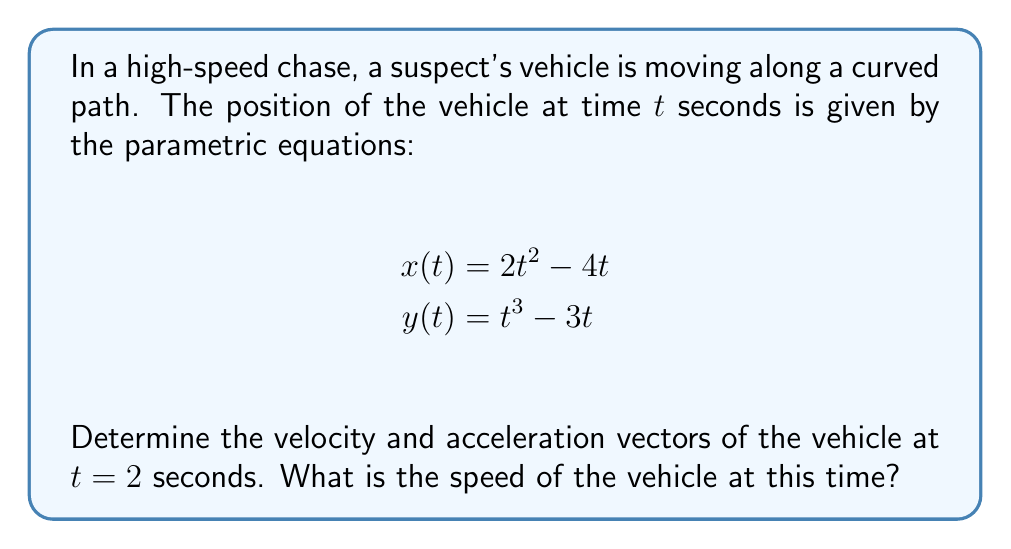Teach me how to tackle this problem. To solve this problem, we need to follow these steps:

1) First, let's find the velocity vector. The velocity vector is the first derivative of the position vector:

   $$\mathbf{v}(t) = \left\langle \frac{dx}{dt}, \frac{dy}{dt} \right\rangle$$

   $$\frac{dx}{dt} = \frac{d}{dt}(2t^2 - 4t) = 4t - 4$$
   $$\frac{dy}{dt} = \frac{d}{dt}(t^3 - 3t) = 3t^2 - 3$$

   So, $$\mathbf{v}(t) = \left\langle 4t - 4, 3t^2 - 3 \right\rangle$$

2) Now, let's find the acceleration vector. The acceleration vector is the second derivative of the position vector, or the first derivative of the velocity vector:

   $$\mathbf{a}(t) = \left\langle \frac{d^2x}{dt^2}, \frac{d^2y}{dt^2} \right\rangle$$

   $$\frac{d^2x}{dt^2} = \frac{d}{dt}(4t - 4) = 4$$
   $$\frac{d^2y}{dt^2} = \frac{d}{dt}(3t^2 - 3) = 6t$$

   So, $$\mathbf{a}(t) = \left\langle 4, 6t \right\rangle$$

3) Now we can evaluate these at $t = 2$:

   $$\mathbf{v}(2) = \left\langle 4(2) - 4, 3(2)^2 - 3 \right\rangle = \left\langle 4, 9 \right\rangle$$
   $$\mathbf{a}(2) = \left\langle 4, 6(2) \right\rangle = \left\langle 4, 12 \right\rangle$$

4) To find the speed at $t = 2$, we need to calculate the magnitude of the velocity vector:

   $$\text{speed} = |\mathbf{v}(2)| = \sqrt{4^2 + 9^2} = \sqrt{16 + 81} = \sqrt{97}$$
Answer: Velocity vector at $t = 2$: $\left\langle 4, 9 \right\rangle$
Acceleration vector at $t = 2$: $\left\langle 4, 12 \right\rangle$
Speed at $t = 2$: $\sqrt{97}$ units/second 